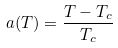Convert formula to latex. <formula><loc_0><loc_0><loc_500><loc_500>a ( T ) = \frac { T - T _ { c } } { T _ { c } }</formula> 